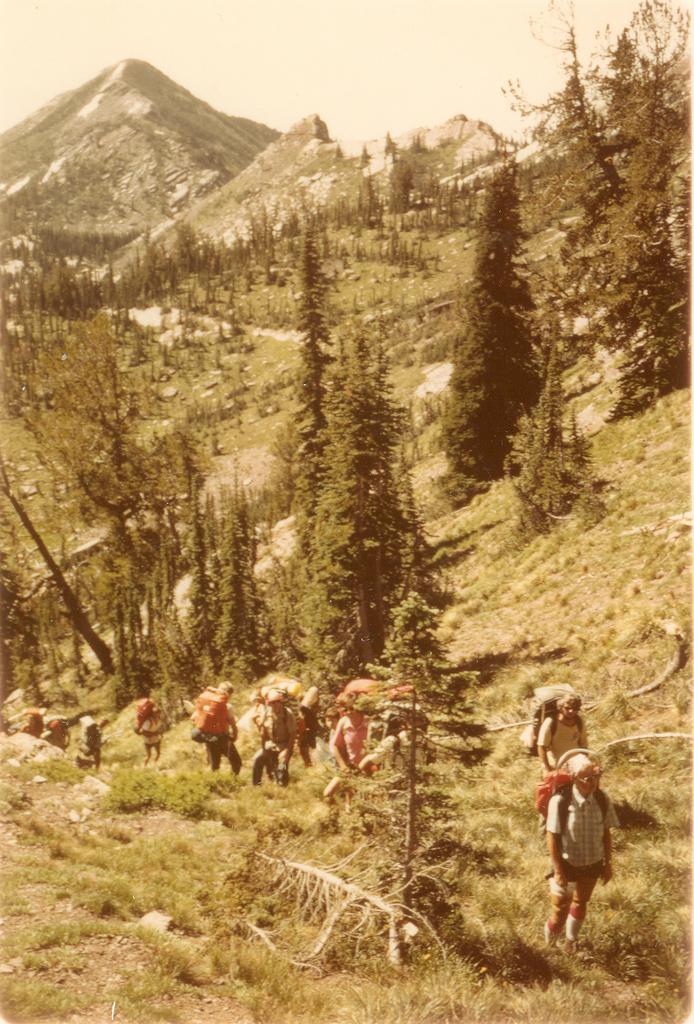Describe this image in one or two sentences. In this image, we can see mountains, trees, grass,stones, plants. Here we can see a group of people are wearing backpacks. 